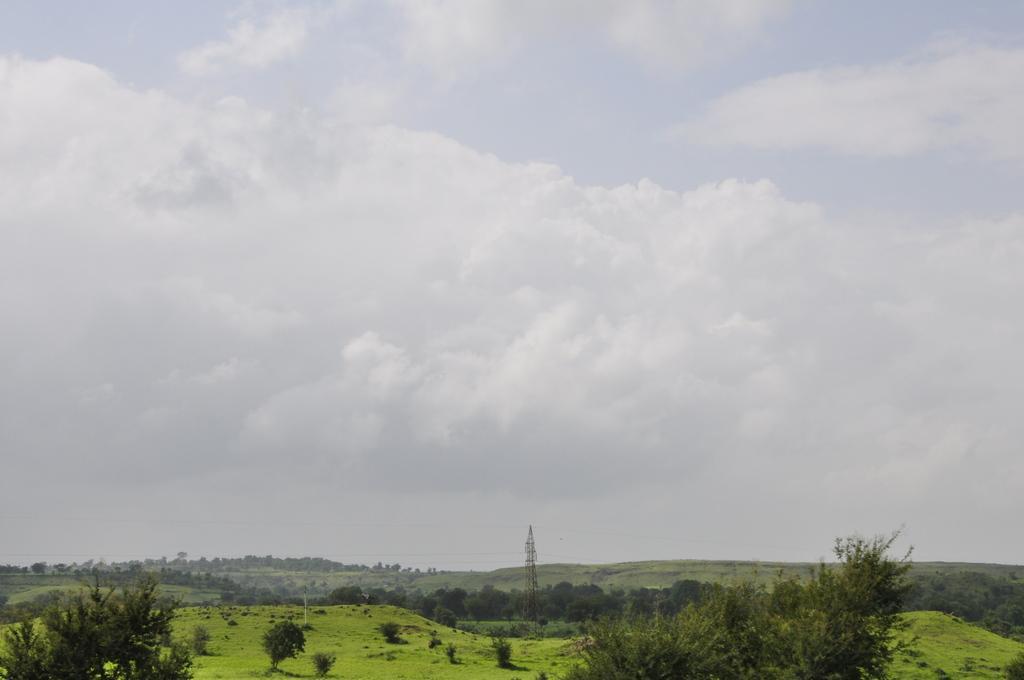Describe this image in one or two sentences. At the bottom of the picture, we see the trees and the grass. In the middle of the picture, we see the radio tower and the wires. There are trees in the background. At the top, we see the sky and the clouds. 